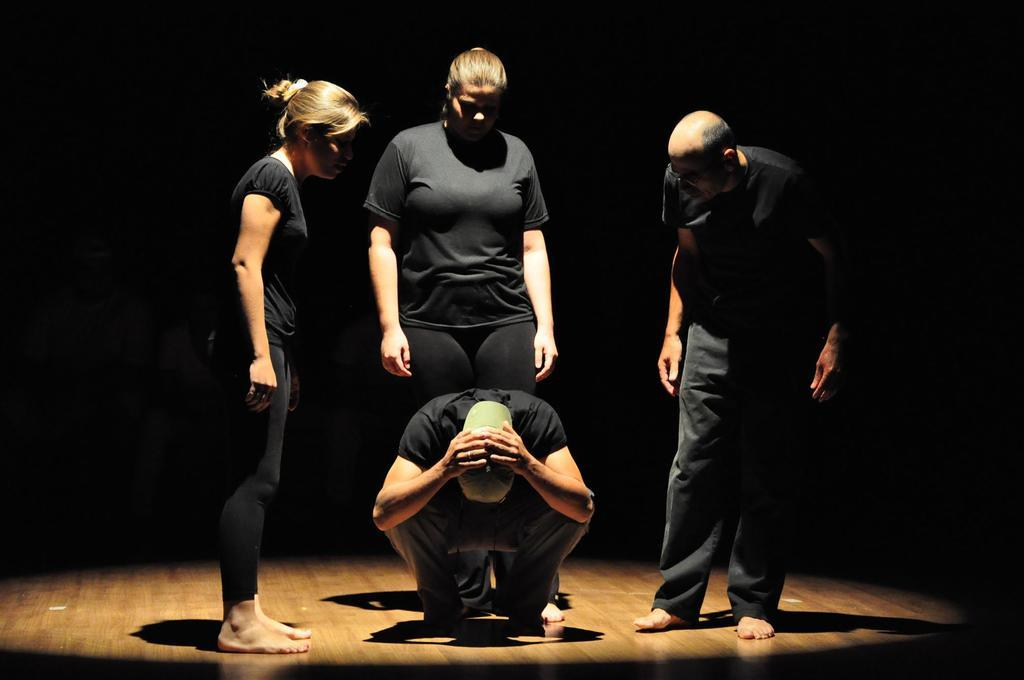How many people are on the platform in the image? There are four people on the platform in the image. Can you describe the person in the center? The person in the center is wearing a cap. What can be observed about the background of the image? The background of the image is dark. How many frogs are sitting on the person's shoulder in the image? There are no frogs present in the image. What type of drain is visible in the image? There is no drain visible in the image. 